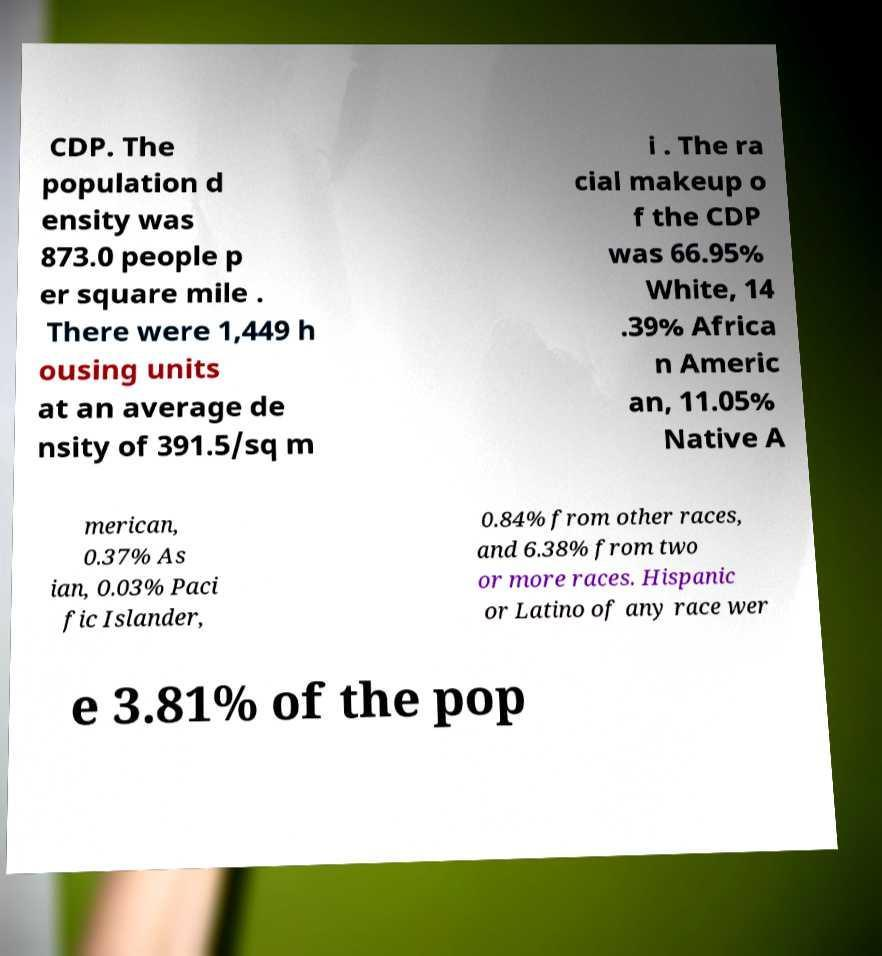Can you read and provide the text displayed in the image?This photo seems to have some interesting text. Can you extract and type it out for me? CDP. The population d ensity was 873.0 people p er square mile . There were 1,449 h ousing units at an average de nsity of 391.5/sq m i . The ra cial makeup o f the CDP was 66.95% White, 14 .39% Africa n Americ an, 11.05% Native A merican, 0.37% As ian, 0.03% Paci fic Islander, 0.84% from other races, and 6.38% from two or more races. Hispanic or Latino of any race wer e 3.81% of the pop 